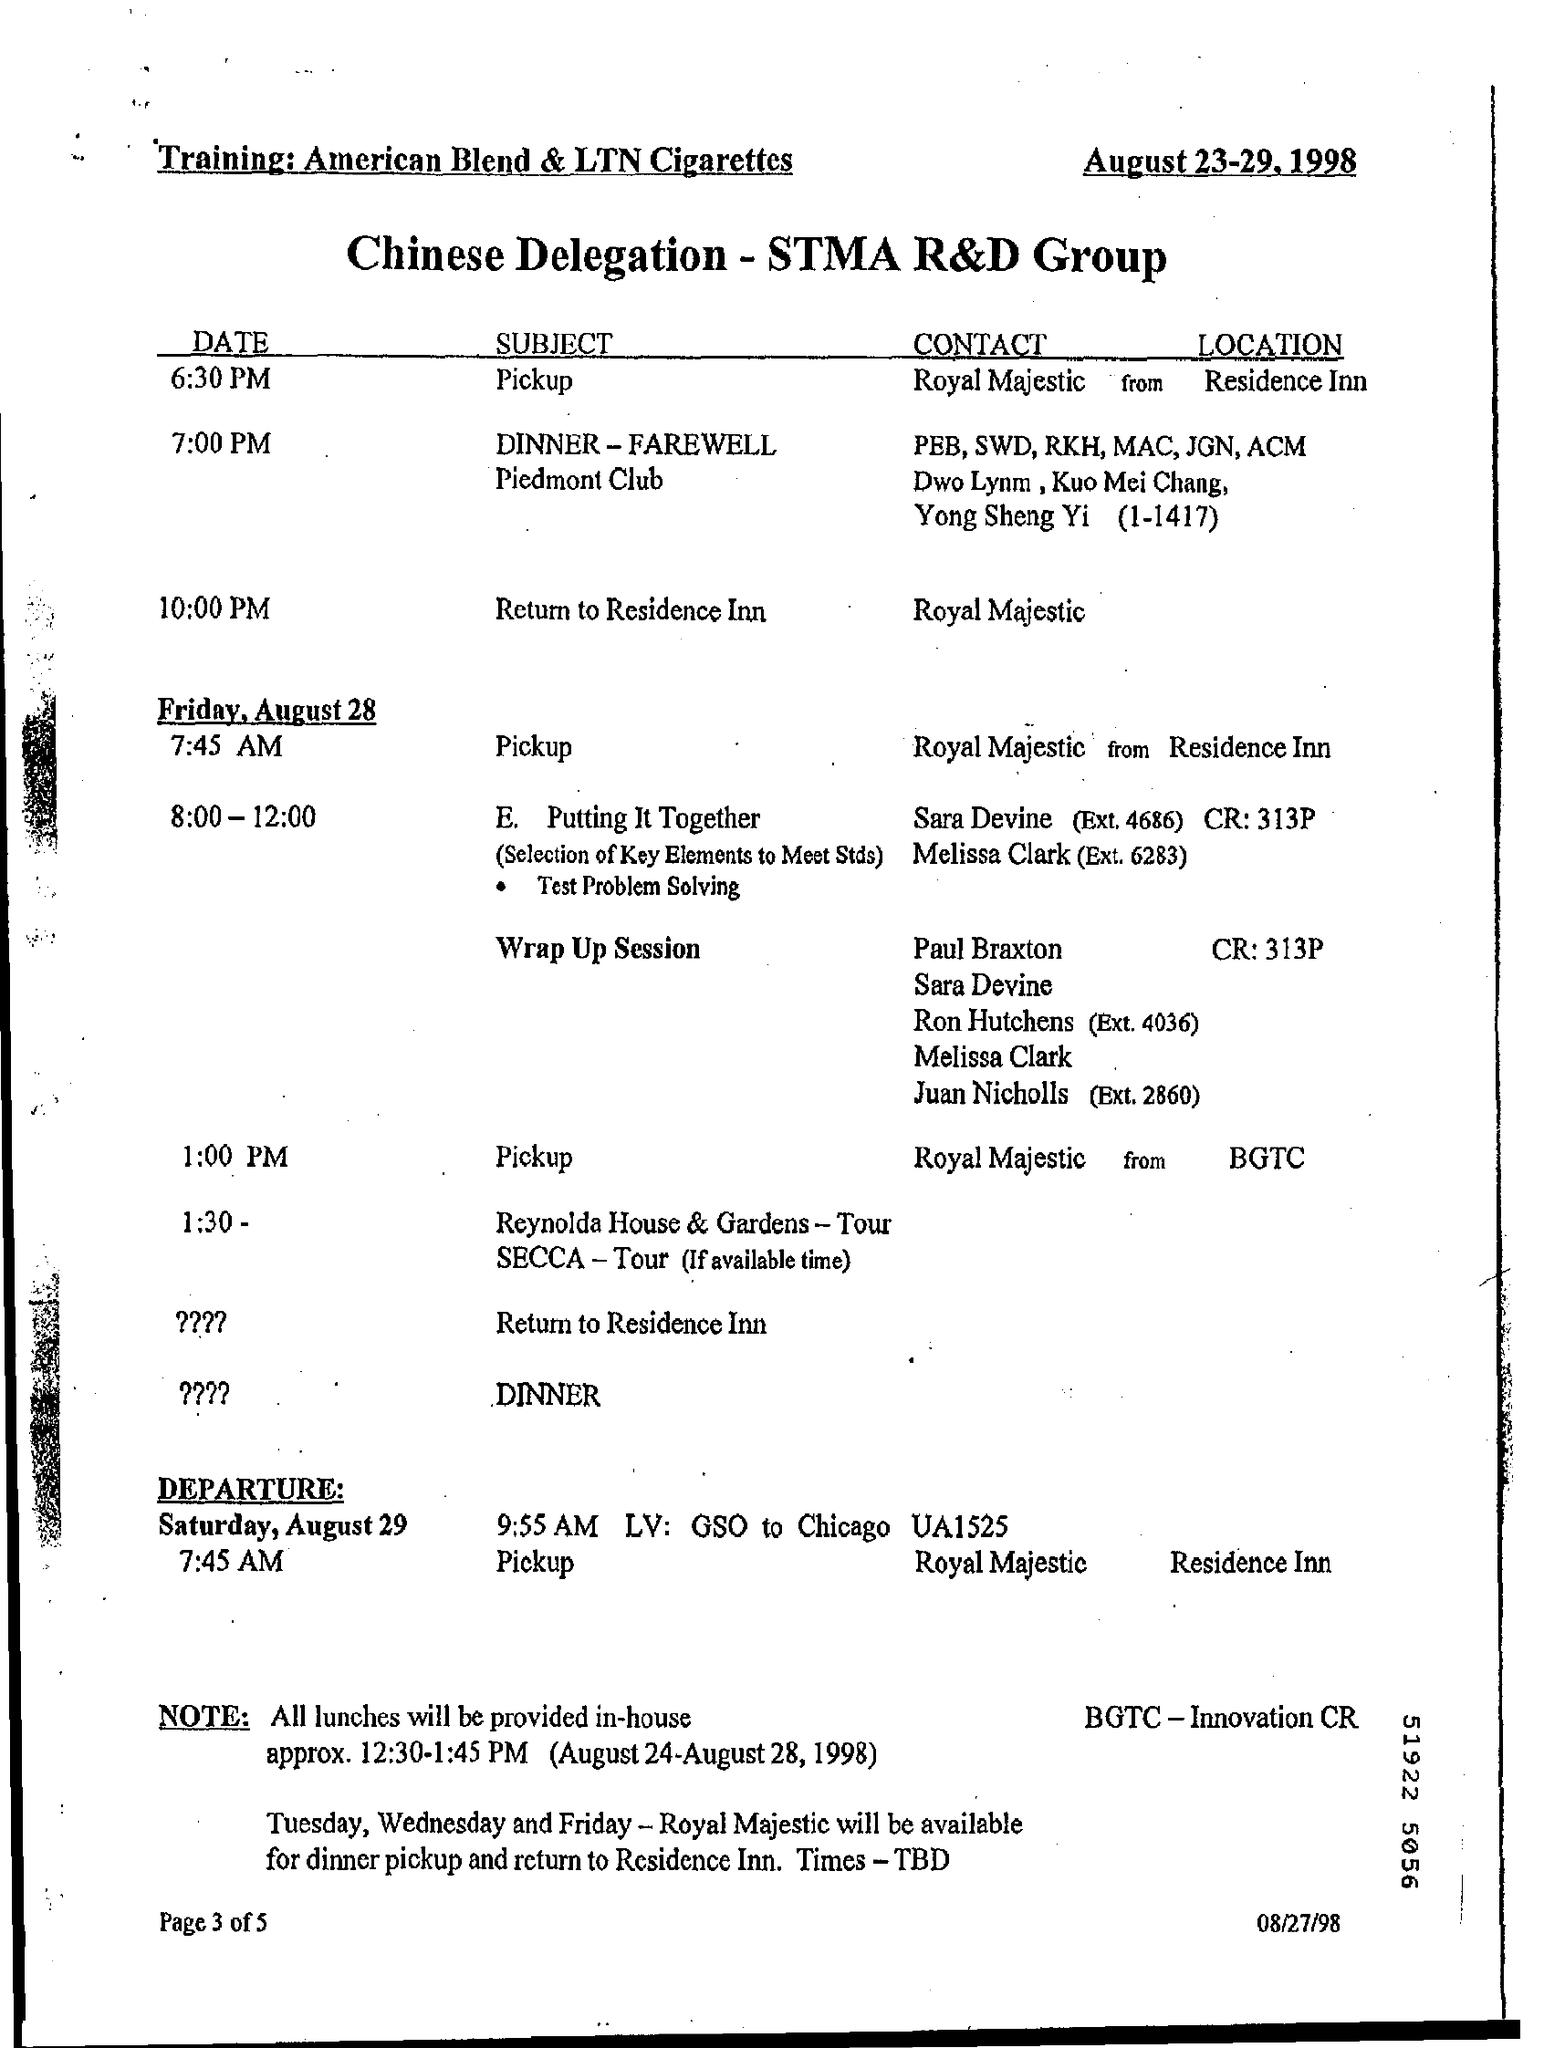What is the date mentioned at the top?
Keep it short and to the point. August 23-29, 1998. What is subject of the event scheduled to Friday August 28 7:45 AM
Keep it short and to the point. Pickup. 